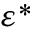<formula> <loc_0><loc_0><loc_500><loc_500>\varepsilon ^ { * }</formula> 